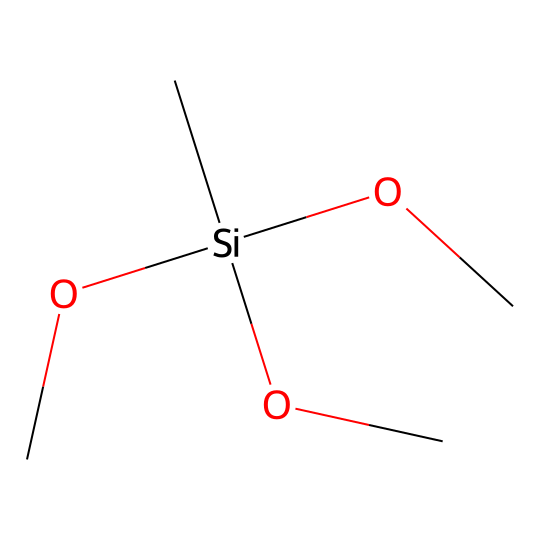How many carbon atoms are present in this compound? Counting the number of carbon atoms in the SMILES representation, we see "C[Si](OC)(OC)OC," which indicates that there are three "C" symbols present.
Answer: three What type of functional groups are present in this silane? The groups labeled as "OC" indicate the presence of methoxy functional groups (-OCH3), which are typical for silanes used as coupling agents.
Answer: methoxy How many silicon-oxygen bonds does this silane have? Each "OC" represents a bond between silicon (Si) and oxygen (O), and there are three such groups linked to the silicon, indicating three silicon-oxygen bonds.
Answer: three What is the general property of silane coupling agents in composites? Silane coupling agents are primarily used to enhance adhesion between the inorganic matrix and organic materials in composites, thus improving mechanical properties and durability.
Answer: adhesion What is the molecular formula derived from this chemical's structure? From the SMILES representation "C[Si](OC)(OC)OC," we derive the molecular formula by counting the atoms: C4H12O3Si (4 carbons, 12 hydrogens, 3 oxygens, and 1 silicon).
Answer: C4H12O3Si What structural feature allows this silane to be effective in composites? The presence of multiple methoxy groups enables the silane to interact with both inorganic surfaces and organic resins, facilitating improved bonding and compatibility within composites.
Answer: multiple methoxy groups 